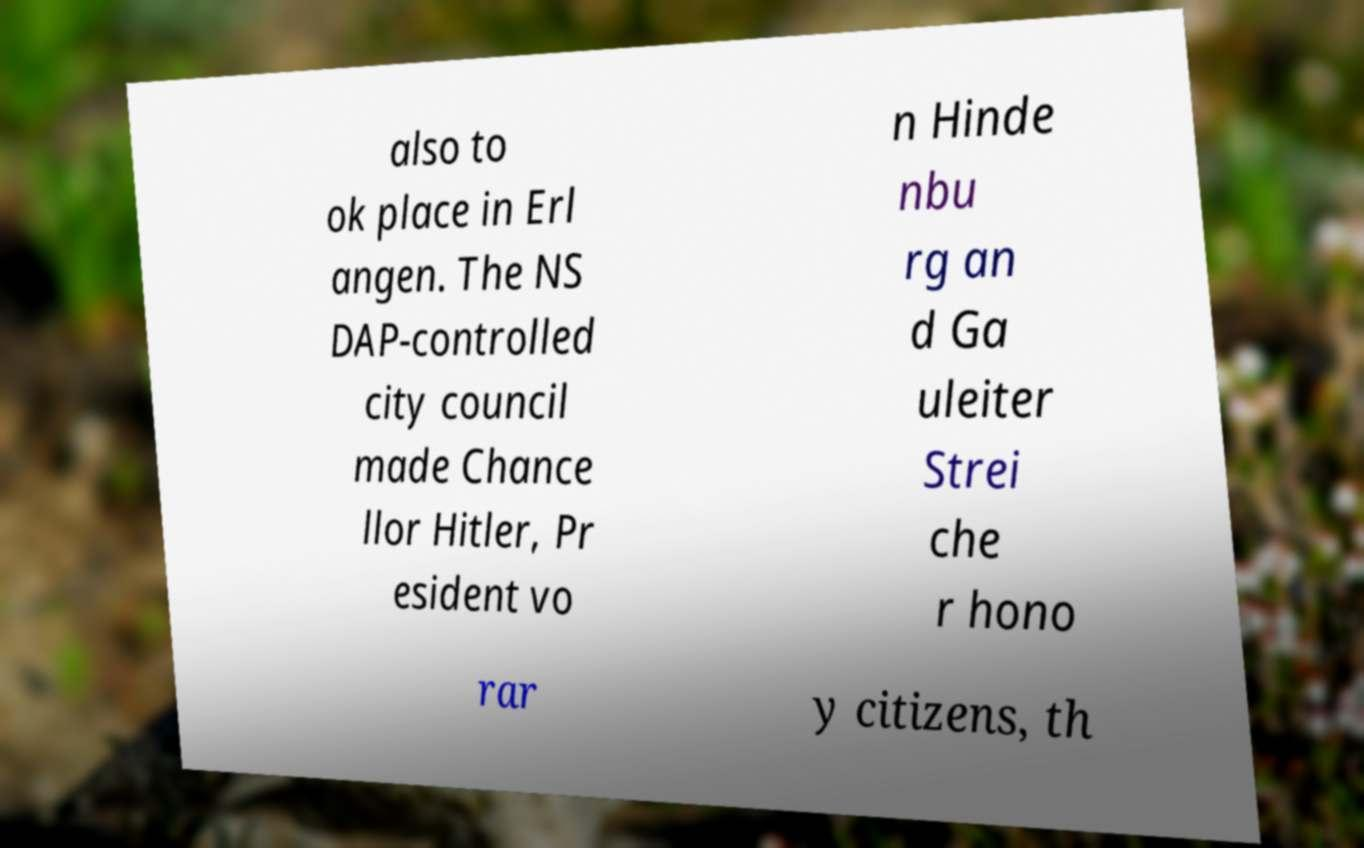There's text embedded in this image that I need extracted. Can you transcribe it verbatim? also to ok place in Erl angen. The NS DAP-controlled city council made Chance llor Hitler, Pr esident vo n Hinde nbu rg an d Ga uleiter Strei che r hono rar y citizens, th 